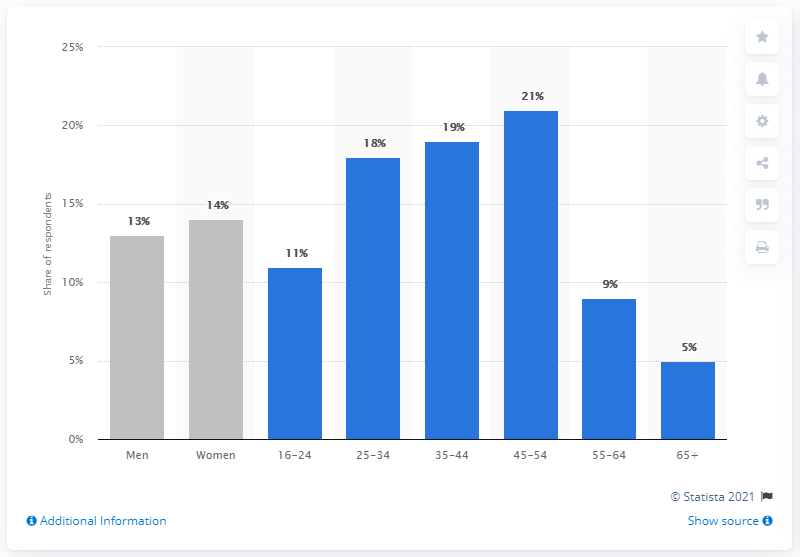Specify some key components in this picture. In the previous three months, 14% of women in Great Britain had purchased food or beverages online. 